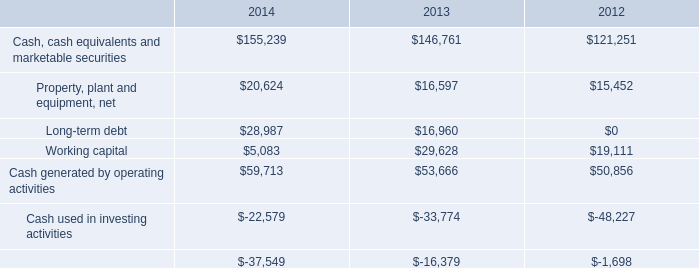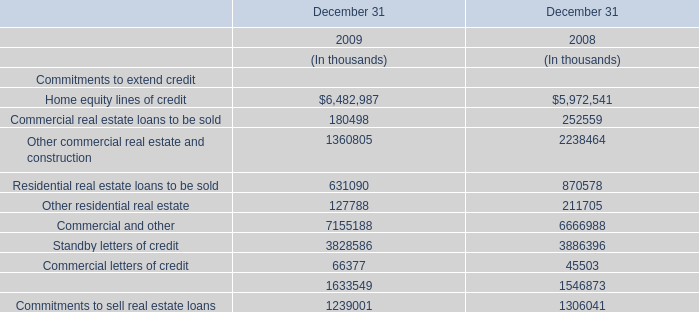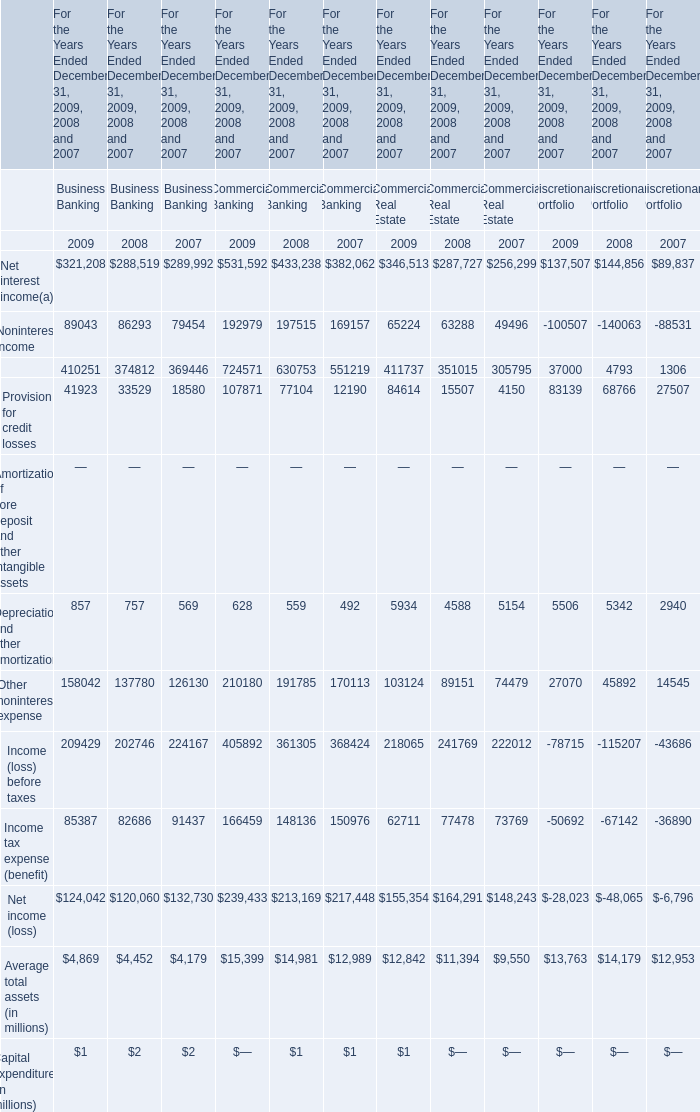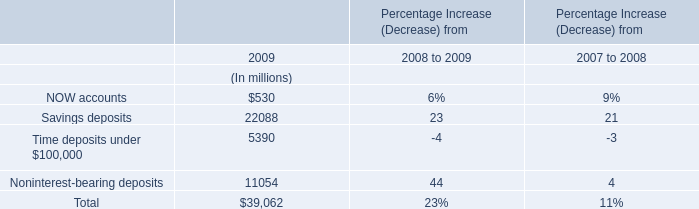Which year is Other noninterest expense for Commercial Banking the highest? 
Answer: 2009. 